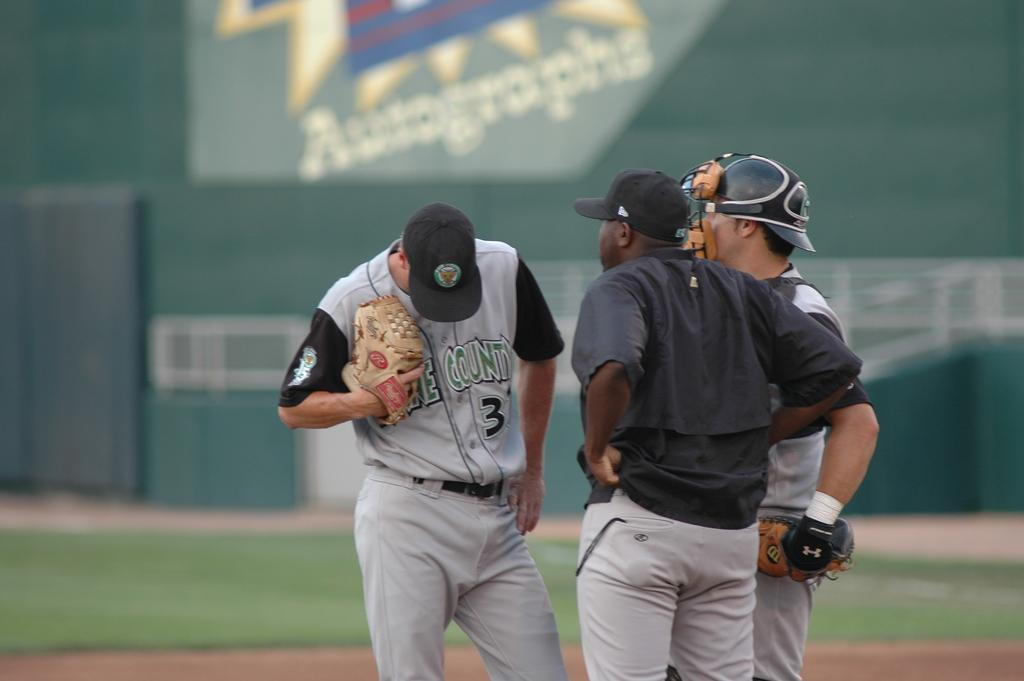How many people are in the image? There are three persons standing in the image. What is the surface beneath the persons' feet? The persons are standing on the ground. What type of vegetation is visible behind the persons? There is grass on the surface behind the persons. What can be seen on the wall in the background? There is a wall with a painting on it in the background. What type of tin can be seen in the image? There is no tin present in the image. What type of produce is being harvested by the persons in the image? There is no produce or harvesting activity depicted in the image. 